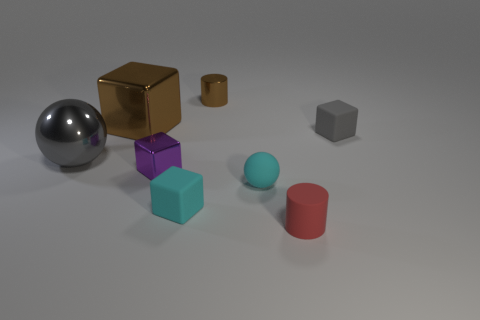Subtract 1 cubes. How many cubes are left? 3 Subtract all gray matte cubes. How many cubes are left? 3 Subtract all gray cubes. How many cubes are left? 3 Subtract all green cubes. Subtract all blue spheres. How many cubes are left? 4 Add 1 tiny cyan spheres. How many objects exist? 9 Subtract all balls. How many objects are left? 6 Add 8 tiny metallic objects. How many tiny metallic objects are left? 10 Add 3 purple shiny blocks. How many purple shiny blocks exist? 4 Subtract 0 yellow cylinders. How many objects are left? 8 Subtract all shiny things. Subtract all tiny red blocks. How many objects are left? 4 